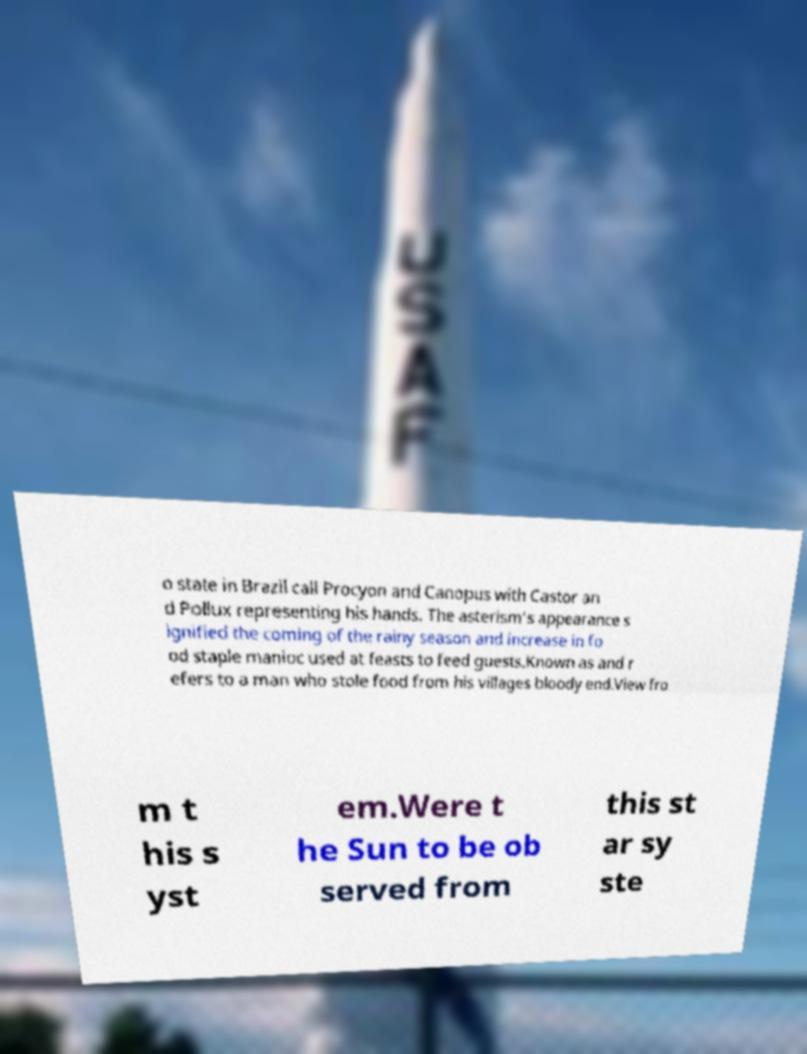Could you extract and type out the text from this image? o state in Brazil call Procyon and Canopus with Castor an d Pollux representing his hands. The asterism's appearance s ignified the coming of the rainy season and increase in fo od staple manioc used at feasts to feed guests.Known as and r efers to a man who stole food from his villages bloody end.View fro m t his s yst em.Were t he Sun to be ob served from this st ar sy ste 